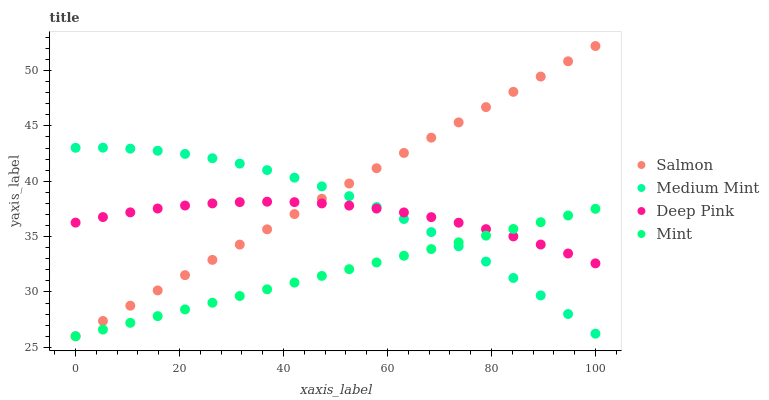Does Mint have the minimum area under the curve?
Answer yes or no. Yes. Does Salmon have the maximum area under the curve?
Answer yes or no. Yes. Does Deep Pink have the minimum area under the curve?
Answer yes or no. No. Does Deep Pink have the maximum area under the curve?
Answer yes or no. No. Is Mint the smoothest?
Answer yes or no. Yes. Is Medium Mint the roughest?
Answer yes or no. Yes. Is Deep Pink the smoothest?
Answer yes or no. No. Is Deep Pink the roughest?
Answer yes or no. No. Does Mint have the lowest value?
Answer yes or no. Yes. Does Deep Pink have the lowest value?
Answer yes or no. No. Does Salmon have the highest value?
Answer yes or no. Yes. Does Deep Pink have the highest value?
Answer yes or no. No. Does Mint intersect Salmon?
Answer yes or no. Yes. Is Mint less than Salmon?
Answer yes or no. No. Is Mint greater than Salmon?
Answer yes or no. No. 